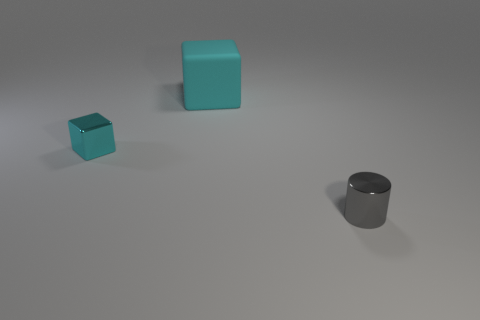There is a cube that is to the left of the cube that is on the right side of the cube that is on the left side of the big matte thing; what size is it?
Provide a succinct answer. Small. How many other objects are the same material as the gray object?
Ensure brevity in your answer.  1. The small thing right of the big cyan matte cube is what color?
Your answer should be very brief. Gray. There is a thing on the left side of the object that is behind the cube to the left of the rubber object; what is it made of?
Your answer should be very brief. Metal. Is there another big thing that has the same shape as the big rubber thing?
Keep it short and to the point. No. What is the shape of the metallic object that is the same size as the cyan metallic block?
Ensure brevity in your answer.  Cylinder. How many objects are on the left side of the shiny cylinder and in front of the cyan rubber block?
Your answer should be very brief. 1. Are there fewer cyan rubber cubes in front of the cyan shiny block than large blocks?
Make the answer very short. Yes. Are there any cyan things that have the same size as the cylinder?
Ensure brevity in your answer.  Yes. There is a small cylinder that is made of the same material as the tiny cyan object; what color is it?
Provide a short and direct response. Gray. 